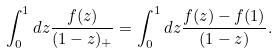Convert formula to latex. <formula><loc_0><loc_0><loc_500><loc_500>\int _ { 0 } ^ { 1 } d z \frac { f ( z ) } { ( 1 - z ) _ { + } } = \int _ { 0 } ^ { 1 } d z \frac { f ( z ) - f ( 1 ) } { ( 1 - z ) } .</formula> 